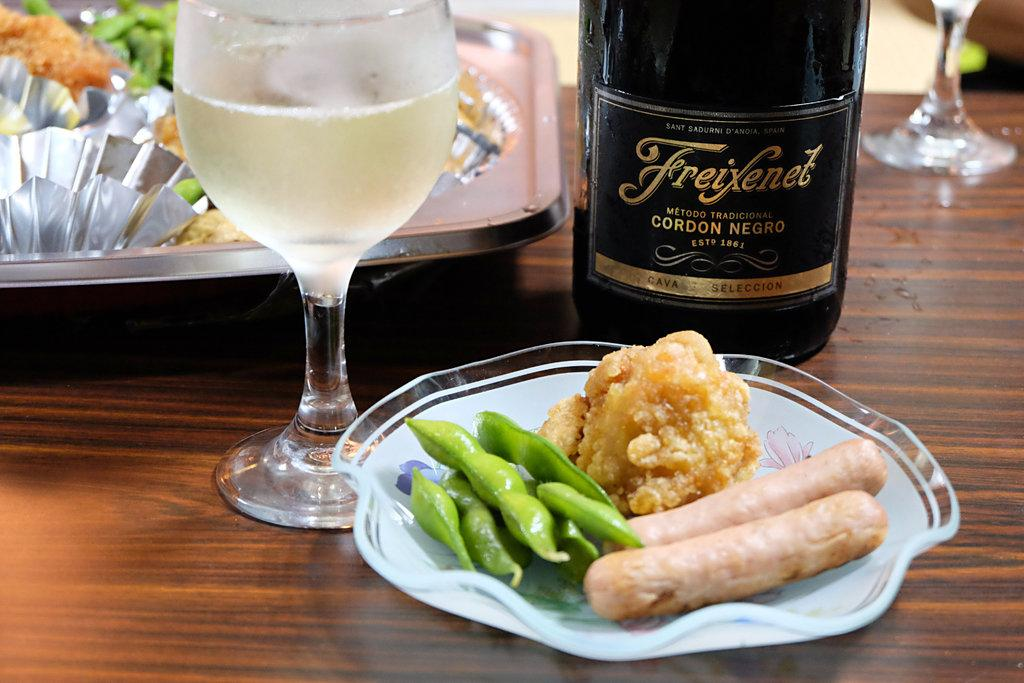<image>
Write a terse but informative summary of the picture. A bottle of Freixenet Cordon Negro is on a table next to a plate of food. 